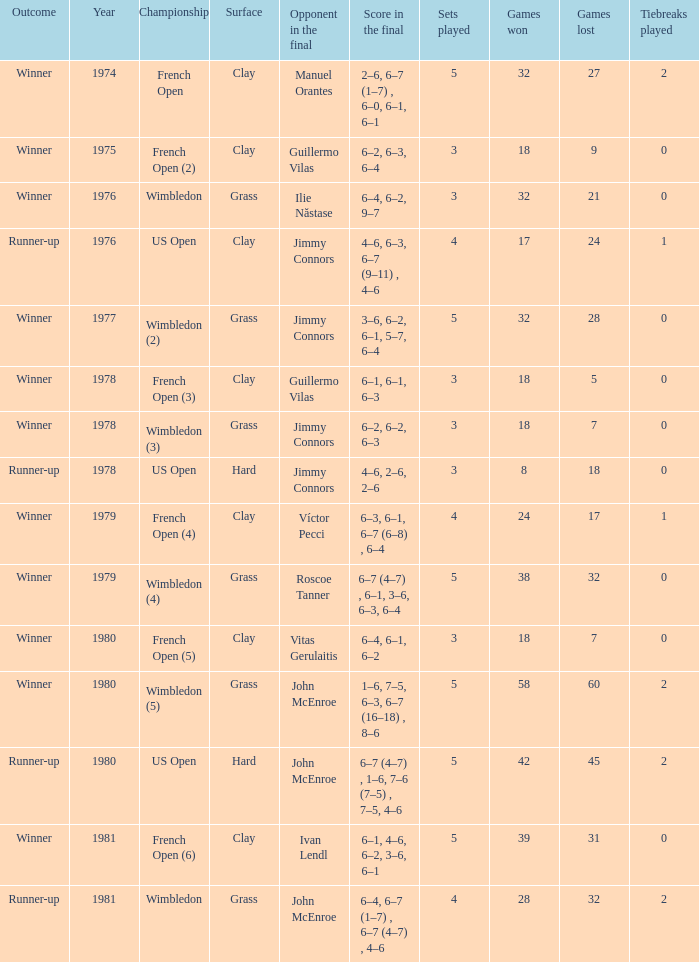What is every score in the final for opponent in final John Mcenroe at US Open? 6–7 (4–7) , 1–6, 7–6 (7–5) , 7–5, 4–6. 